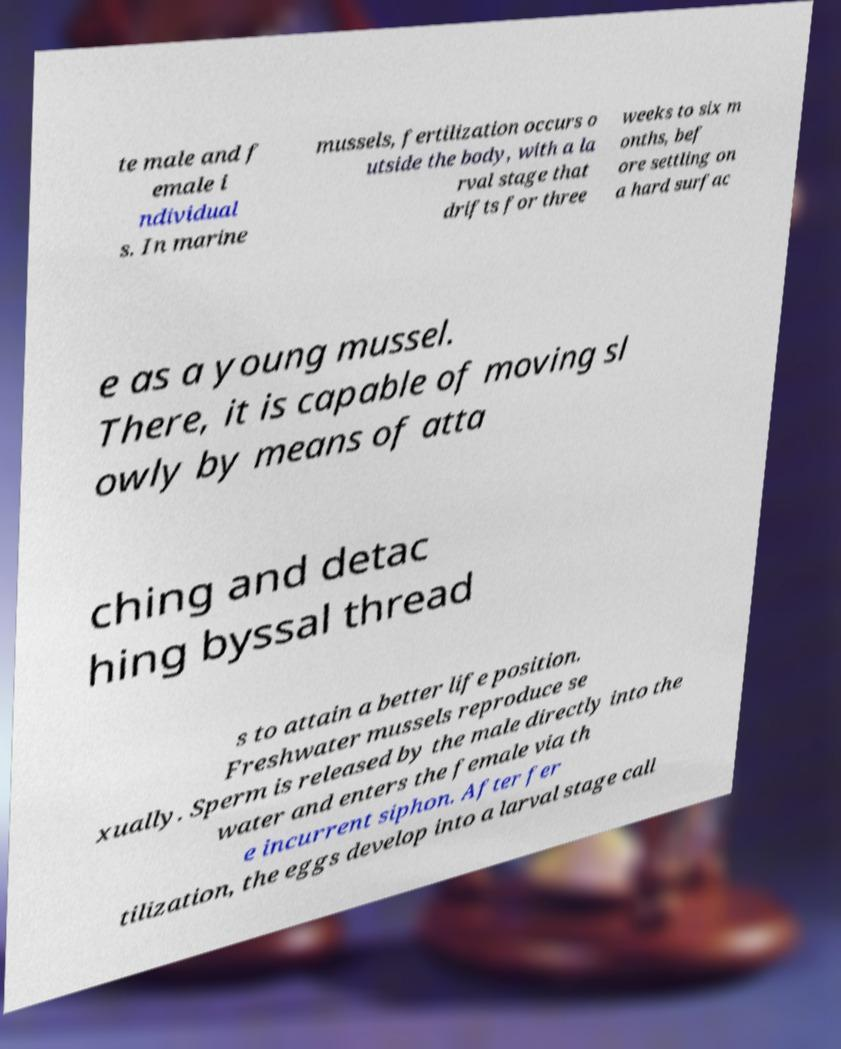Can you read and provide the text displayed in the image?This photo seems to have some interesting text. Can you extract and type it out for me? te male and f emale i ndividual s. In marine mussels, fertilization occurs o utside the body, with a la rval stage that drifts for three weeks to six m onths, bef ore settling on a hard surfac e as a young mussel. There, it is capable of moving sl owly by means of atta ching and detac hing byssal thread s to attain a better life position. Freshwater mussels reproduce se xually. Sperm is released by the male directly into the water and enters the female via th e incurrent siphon. After fer tilization, the eggs develop into a larval stage call 